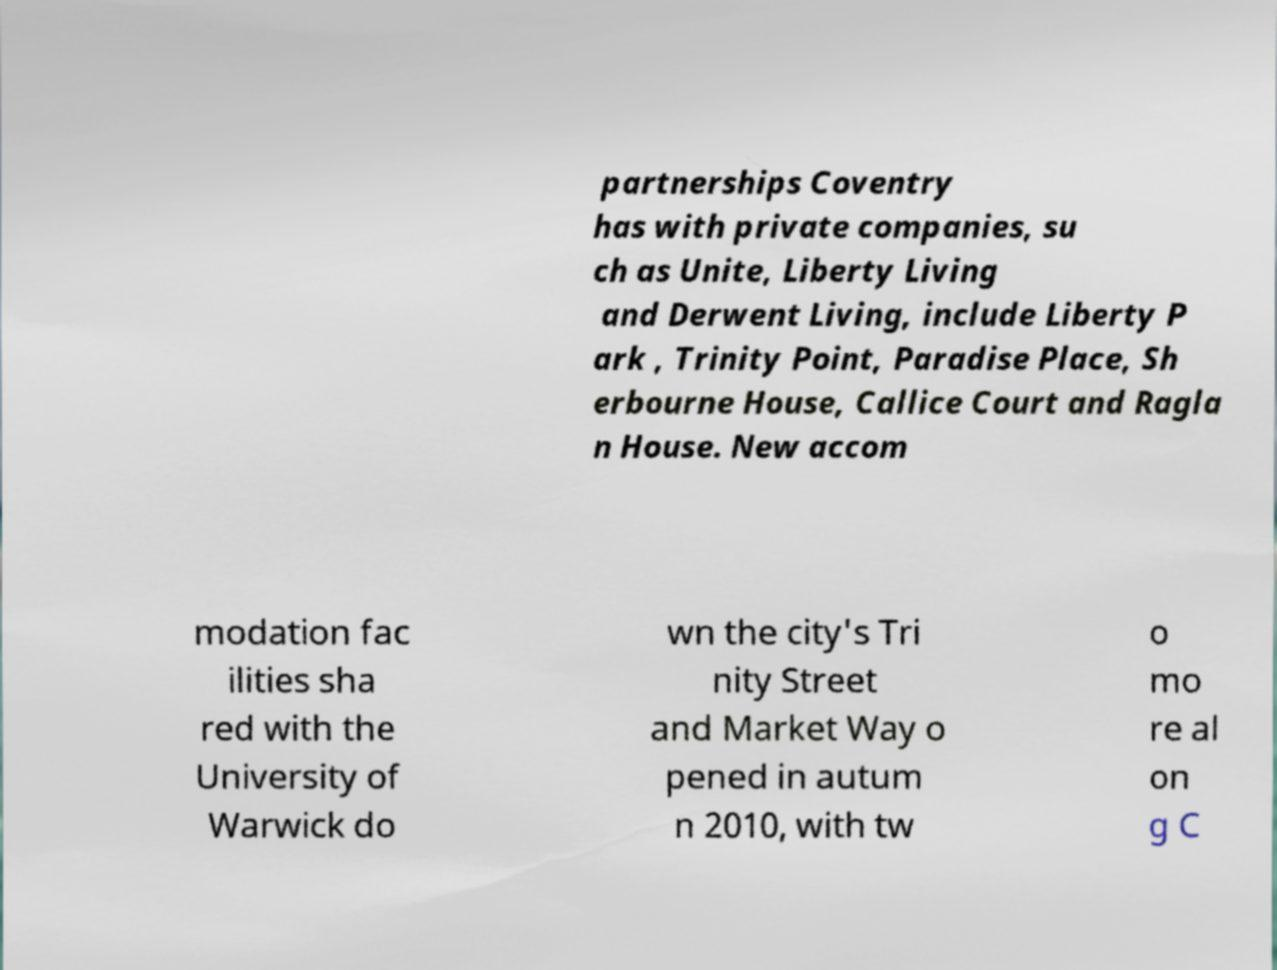There's text embedded in this image that I need extracted. Can you transcribe it verbatim? partnerships Coventry has with private companies, su ch as Unite, Liberty Living and Derwent Living, include Liberty P ark , Trinity Point, Paradise Place, Sh erbourne House, Callice Court and Ragla n House. New accom modation fac ilities sha red with the University of Warwick do wn the city's Tri nity Street and Market Way o pened in autum n 2010, with tw o mo re al on g C 